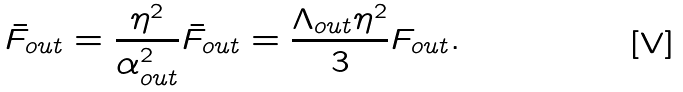Convert formula to latex. <formula><loc_0><loc_0><loc_500><loc_500>\bar { F } _ { o u t } = \frac { \eta ^ { 2 } } { \alpha _ { o u t } ^ { 2 } } \bar { F } _ { o u t } = \frac { \Lambda _ { o u t } \eta ^ { 2 } } { 3 } F _ { o u t } .</formula> 